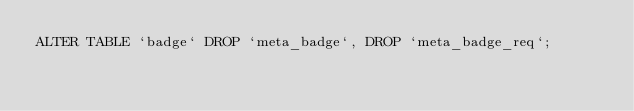<code> <loc_0><loc_0><loc_500><loc_500><_SQL_>ALTER TABLE `badge` DROP `meta_badge`, DROP `meta_badge_req`;</code> 